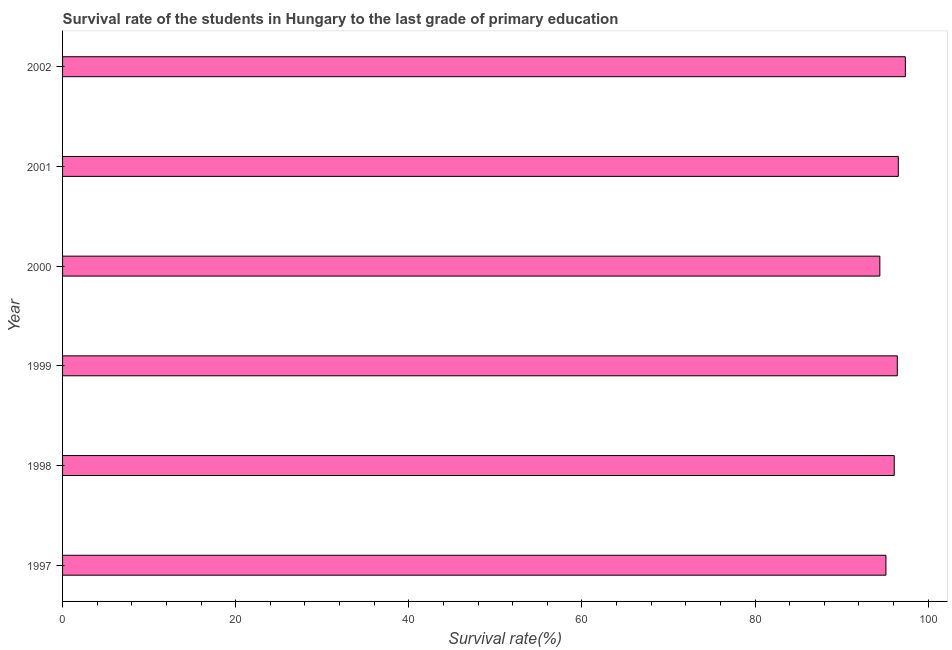Does the graph contain any zero values?
Your response must be concise. No. Does the graph contain grids?
Provide a short and direct response. No. What is the title of the graph?
Your response must be concise. Survival rate of the students in Hungary to the last grade of primary education. What is the label or title of the X-axis?
Keep it short and to the point. Survival rate(%). What is the label or title of the Y-axis?
Your response must be concise. Year. What is the survival rate in primary education in 2001?
Keep it short and to the point. 96.55. Across all years, what is the maximum survival rate in primary education?
Your response must be concise. 97.36. Across all years, what is the minimum survival rate in primary education?
Your answer should be compact. 94.41. In which year was the survival rate in primary education maximum?
Provide a succinct answer. 2002. In which year was the survival rate in primary education minimum?
Your answer should be compact. 2000. What is the sum of the survival rate in primary education?
Ensure brevity in your answer.  575.94. What is the difference between the survival rate in primary education in 2000 and 2001?
Your answer should be compact. -2.13. What is the average survival rate in primary education per year?
Your answer should be compact. 95.99. What is the median survival rate in primary education?
Make the answer very short. 96.25. What is the ratio of the survival rate in primary education in 1999 to that in 2002?
Ensure brevity in your answer.  0.99. Is the survival rate in primary education in 2000 less than that in 2001?
Make the answer very short. Yes. What is the difference between the highest and the second highest survival rate in primary education?
Offer a terse response. 0.81. Is the sum of the survival rate in primary education in 1997 and 2000 greater than the maximum survival rate in primary education across all years?
Offer a very short reply. Yes. What is the difference between the highest and the lowest survival rate in primary education?
Offer a terse response. 2.95. In how many years, is the survival rate in primary education greater than the average survival rate in primary education taken over all years?
Ensure brevity in your answer.  4. Are the values on the major ticks of X-axis written in scientific E-notation?
Provide a short and direct response. No. What is the Survival rate(%) in 1997?
Offer a terse response. 95.12. What is the Survival rate(%) of 1998?
Provide a succinct answer. 96.08. What is the Survival rate(%) of 1999?
Offer a very short reply. 96.43. What is the Survival rate(%) of 2000?
Offer a very short reply. 94.41. What is the Survival rate(%) in 2001?
Provide a short and direct response. 96.55. What is the Survival rate(%) of 2002?
Your answer should be very brief. 97.36. What is the difference between the Survival rate(%) in 1997 and 1998?
Provide a short and direct response. -0.96. What is the difference between the Survival rate(%) in 1997 and 1999?
Provide a succinct answer. -1.31. What is the difference between the Survival rate(%) in 1997 and 2000?
Offer a terse response. 0.7. What is the difference between the Survival rate(%) in 1997 and 2001?
Offer a very short reply. -1.43. What is the difference between the Survival rate(%) in 1997 and 2002?
Provide a succinct answer. -2.24. What is the difference between the Survival rate(%) in 1998 and 1999?
Give a very brief answer. -0.35. What is the difference between the Survival rate(%) in 1998 and 2000?
Provide a succinct answer. 1.66. What is the difference between the Survival rate(%) in 1998 and 2001?
Offer a terse response. -0.47. What is the difference between the Survival rate(%) in 1998 and 2002?
Offer a very short reply. -1.28. What is the difference between the Survival rate(%) in 1999 and 2000?
Offer a terse response. 2.02. What is the difference between the Survival rate(%) in 1999 and 2001?
Offer a very short reply. -0.12. What is the difference between the Survival rate(%) in 1999 and 2002?
Your answer should be compact. -0.93. What is the difference between the Survival rate(%) in 2000 and 2001?
Your answer should be very brief. -2.13. What is the difference between the Survival rate(%) in 2000 and 2002?
Your answer should be very brief. -2.95. What is the difference between the Survival rate(%) in 2001 and 2002?
Your answer should be very brief. -0.81. What is the ratio of the Survival rate(%) in 1997 to that in 2002?
Provide a short and direct response. 0.98. What is the ratio of the Survival rate(%) in 1999 to that in 2000?
Provide a succinct answer. 1.02. What is the ratio of the Survival rate(%) in 1999 to that in 2001?
Provide a succinct answer. 1. What is the ratio of the Survival rate(%) in 2000 to that in 2001?
Your response must be concise. 0.98. What is the ratio of the Survival rate(%) in 2001 to that in 2002?
Offer a very short reply. 0.99. 